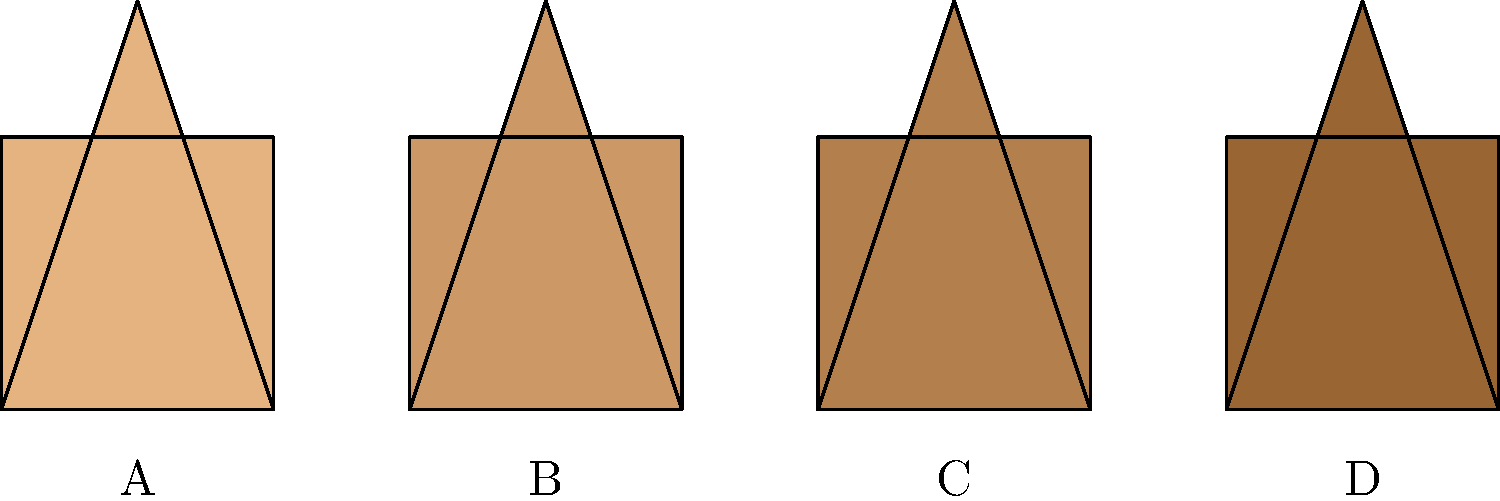Arrange the following representations of Dutch architectural styles from oldest to most recent: 

A) Step-gable house
B) Canal house
C) Dutch Baroque house
D) Modern Dutch house To arrange these Dutch architectural styles chronologically, we need to consider their historical development:

1. Step-gable house (A): This style originated in the late medieval period, around the 15th-16th centuries. It's characterized by its distinctive stepped gable facade.

2. Canal house (B): These emerged during the Dutch Golden Age in the 17th century. They're narrow, tall houses built along the canals of Amsterdam and other Dutch cities.

3. Dutch Baroque house (C): This style became popular in the late 17th and early 18th centuries, influenced by the broader European Baroque movement.

4. Modern Dutch house (D): This represents contemporary Dutch architecture from the 20th century onwards, incorporating modern materials and design principles.

Therefore, the correct chronological order from oldest to most recent is: A, B, C, D.
Answer: A, B, C, D 